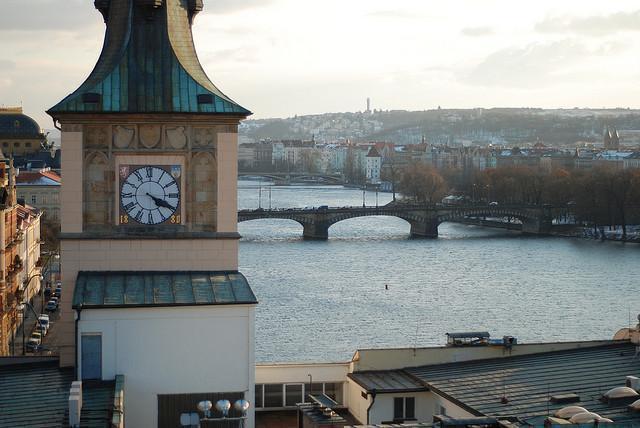What do the numbers on either side of the clock represent?
Choose the correct response and explain in the format: 'Answer: answer
Rationale: rationale.'
Options: Nothing, name, date, time. Answer: date.
Rationale: They are for decoration. 